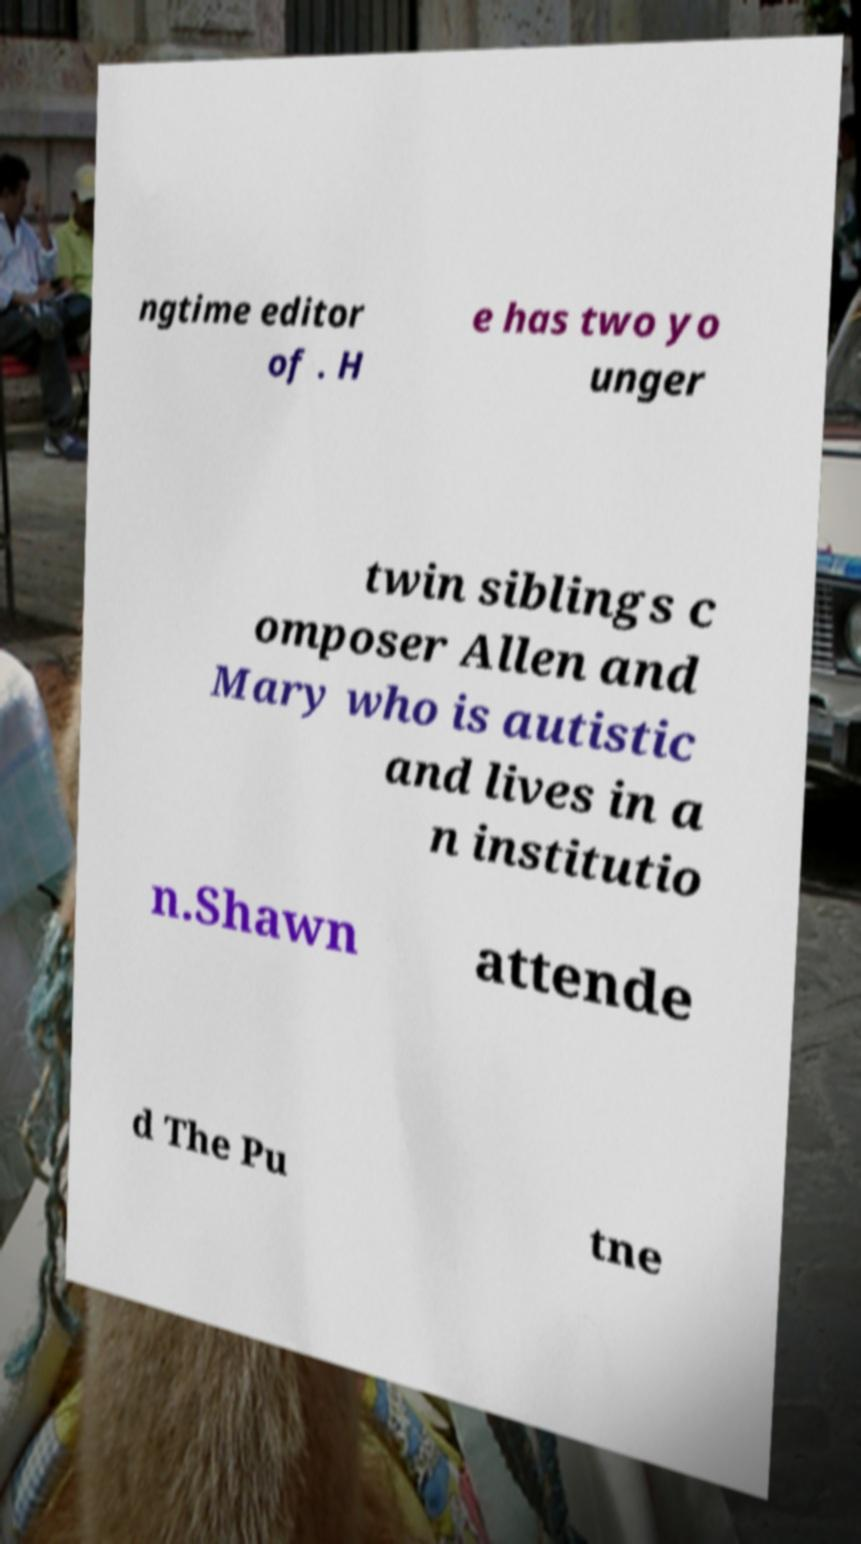For documentation purposes, I need the text within this image transcribed. Could you provide that? ngtime editor of . H e has two yo unger twin siblings c omposer Allen and Mary who is autistic and lives in a n institutio n.Shawn attende d The Pu tne 